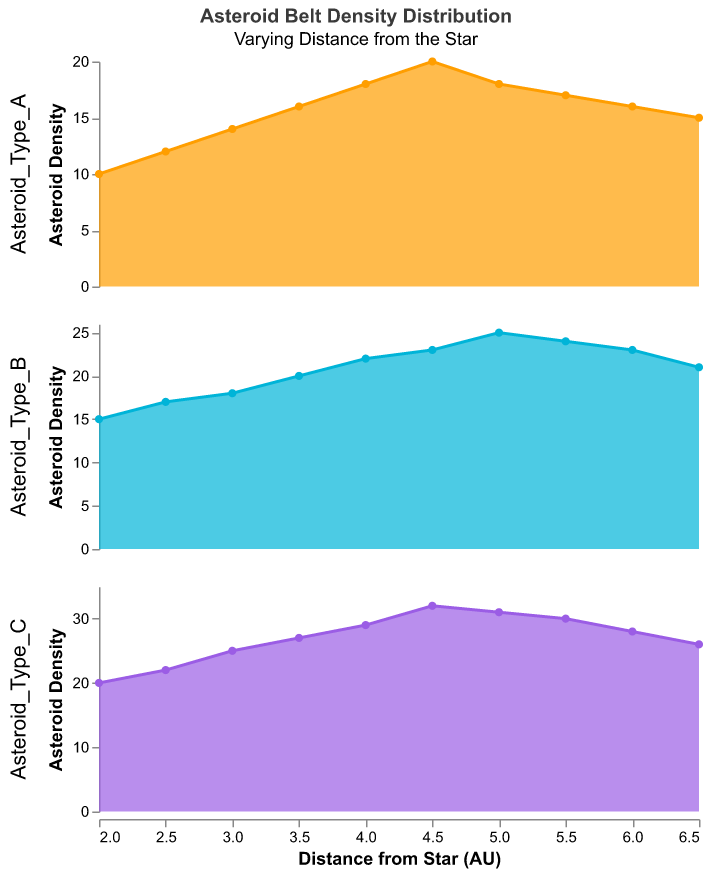What's the title of the chart? The visual representation usually has the title at the top to give viewers a quick understanding of what the chart represents. Here, the title is present at the top.
Answer: Asteroid Belt Density Distribution How many subplots are in the figure? The figure splits the data into multiple subplots, one for each asteroid type. There are three asteroid types shown.
Answer: 3 What are the asteroid types shown in the subplots? The subplots represent different categories labeled in the chart. Here, the asteroid types are indicated in the legend or headings of the rows.
Answer: Asteroid_Type_A, Asteroid_Type_B, Asteroid_Type_C What is the asteroid density for Asteroid_Type_A at 4 AU distance from the Star? Look at the subplot for Asteroid_Type_A and find the asteroid density value at the 4 AU mark on the x-axis.
Answer: 18 Which asteroid type shows the highest density at the largest distance from the star? Compare the densities of all asteroid types at the largest distance (6.5 AU). Check the highest value amongst the three densities.
Answer: Asteroid_Type_C Is the density trend for Asteroid_Type_B increasing or decreasing as the distance from the star increases? Examine the trend line in the subplot for Asteroid_Type_B from lower to higher distances (AU). Observe if it generally ascends or descends.
Answer: Increasing What is the maximum asteroid density for Asteroid_Type_C? Check the highest point in the subplot for Asteroid_Type_C, which indicates the maximum density.
Answer: 32 At what distance from the star does Asteroid_Type_B exceed a density of 20? In the subplot for Asteroid_Type_B, find the point where the density crosses the 20 mark for the first time and note the corresponding distance on the x-axis.
Answer: 3.5 AU Compare the density values of Asteroid_Type_A and Asteroid_Type_C at 5 AU distance. Which one is higher and by how much? Look for the density values at 5 AU for both Asteroid_Type_A and Asteroid_Type_C and find the difference between them.
Answer: Asteroid_Type_C is higher by 13 At which distance do Asteroid_Type_A and Asteroid_Type_B have the same density, or are they never the same? Check if there is any point along the x-axis where the Asteroid_Type_A and Asteroid_Type_B density lines intersect or match.
Answer: 4.5 AU 